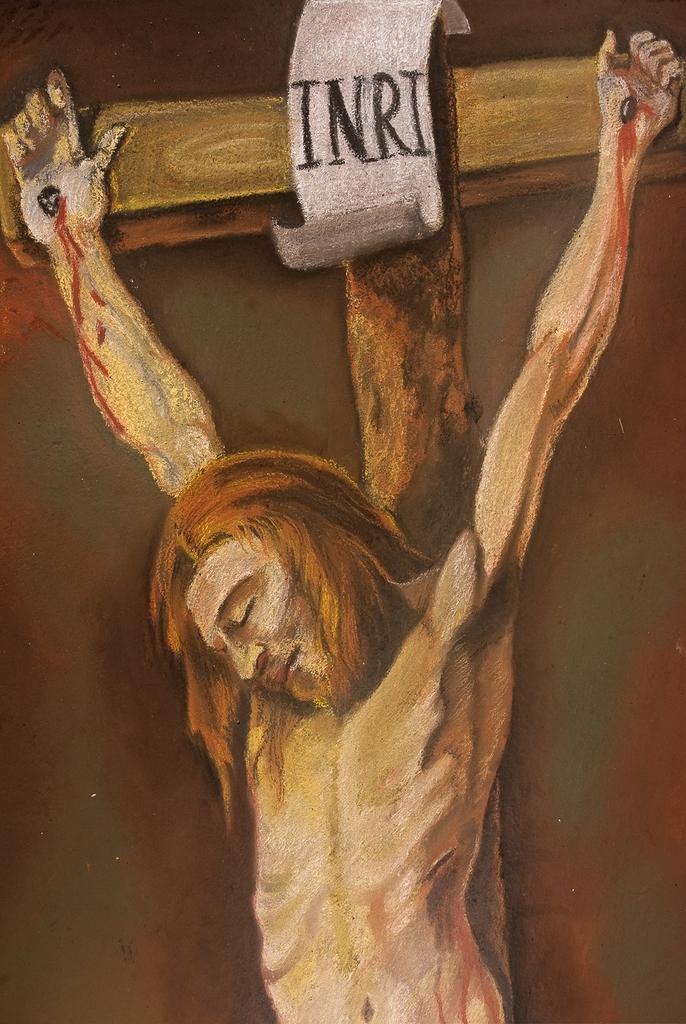How would you summarize this image in a sentence or two? In this picture I can observe a painting of Jesus. Behind the Jesus there is a cross. 